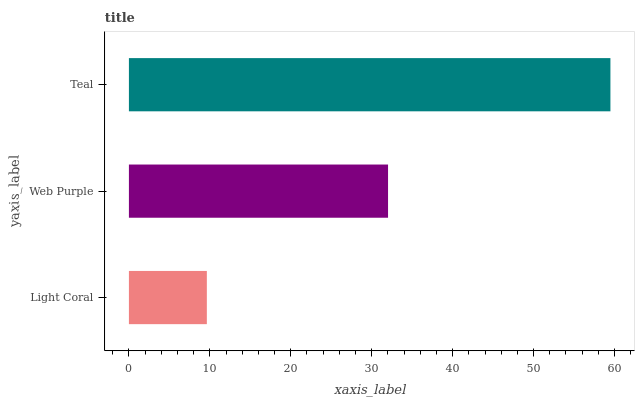Is Light Coral the minimum?
Answer yes or no. Yes. Is Teal the maximum?
Answer yes or no. Yes. Is Web Purple the minimum?
Answer yes or no. No. Is Web Purple the maximum?
Answer yes or no. No. Is Web Purple greater than Light Coral?
Answer yes or no. Yes. Is Light Coral less than Web Purple?
Answer yes or no. Yes. Is Light Coral greater than Web Purple?
Answer yes or no. No. Is Web Purple less than Light Coral?
Answer yes or no. No. Is Web Purple the high median?
Answer yes or no. Yes. Is Web Purple the low median?
Answer yes or no. Yes. Is Light Coral the high median?
Answer yes or no. No. Is Light Coral the low median?
Answer yes or no. No. 